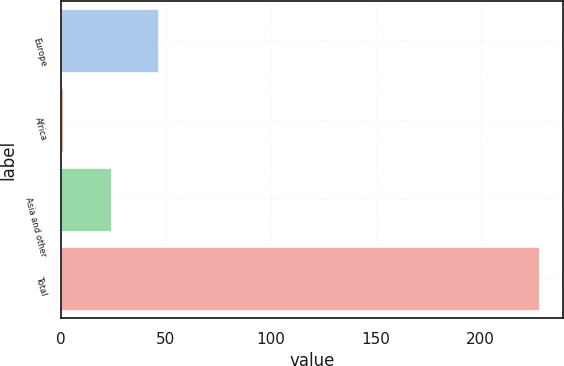Convert chart. <chart><loc_0><loc_0><loc_500><loc_500><bar_chart><fcel>Europe<fcel>Africa<fcel>Asia and other<fcel>Total<nl><fcel>46.4<fcel>1<fcel>23.7<fcel>228<nl></chart> 